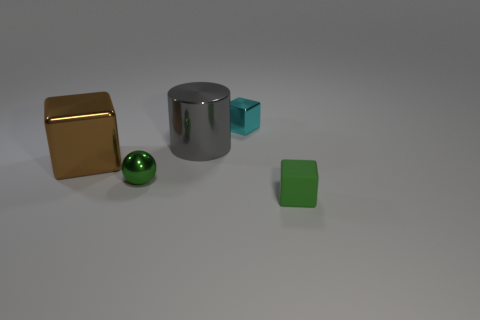Subtract all big brown metallic blocks. How many blocks are left? 2 Add 2 tiny blue rubber cubes. How many objects exist? 7 Subtract all cubes. How many objects are left? 2 Add 3 small green metallic objects. How many small green metallic objects exist? 4 Subtract 0 cyan cylinders. How many objects are left? 5 Subtract all gray blocks. Subtract all brown cylinders. How many blocks are left? 3 Subtract all green shiny objects. Subtract all tiny shiny spheres. How many objects are left? 3 Add 1 cubes. How many cubes are left? 4 